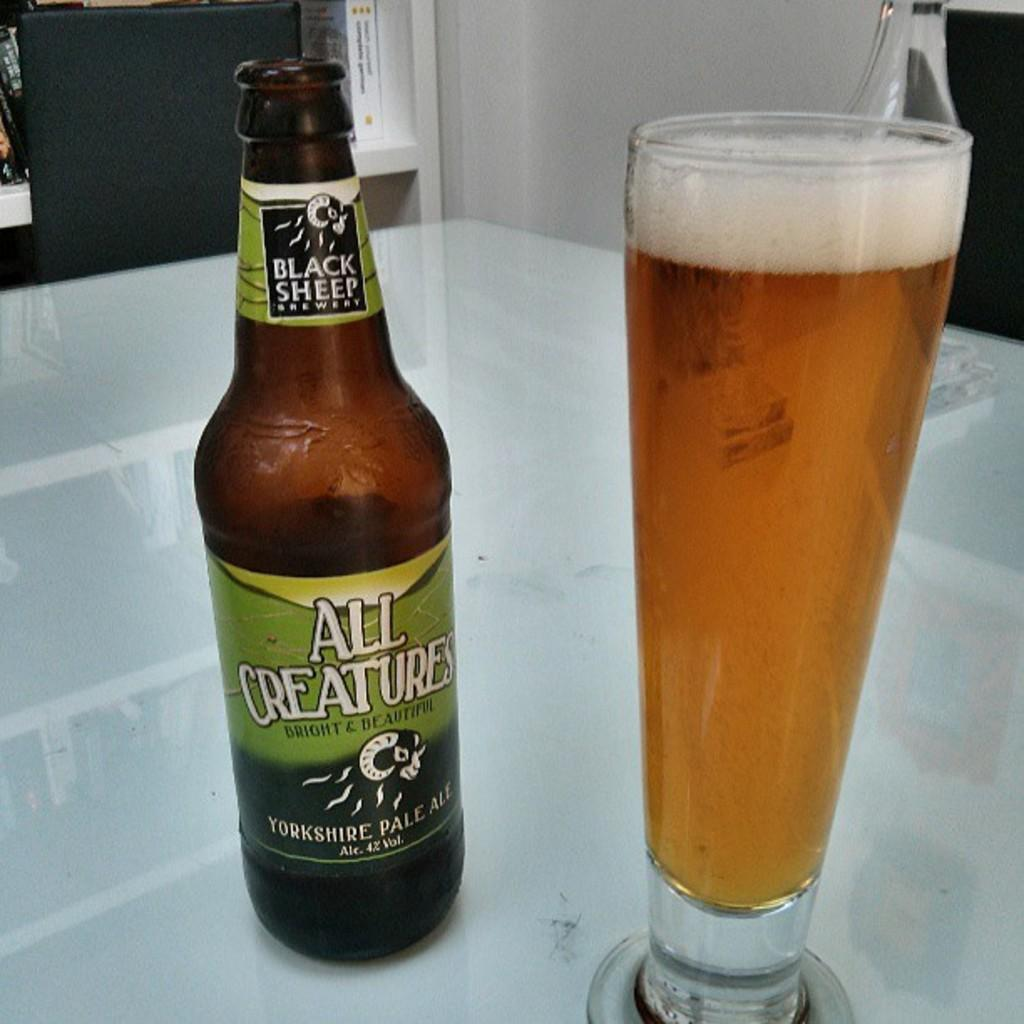<image>
Summarize the visual content of the image. A bottle of All Creatures brand ale is next to a full glass. 